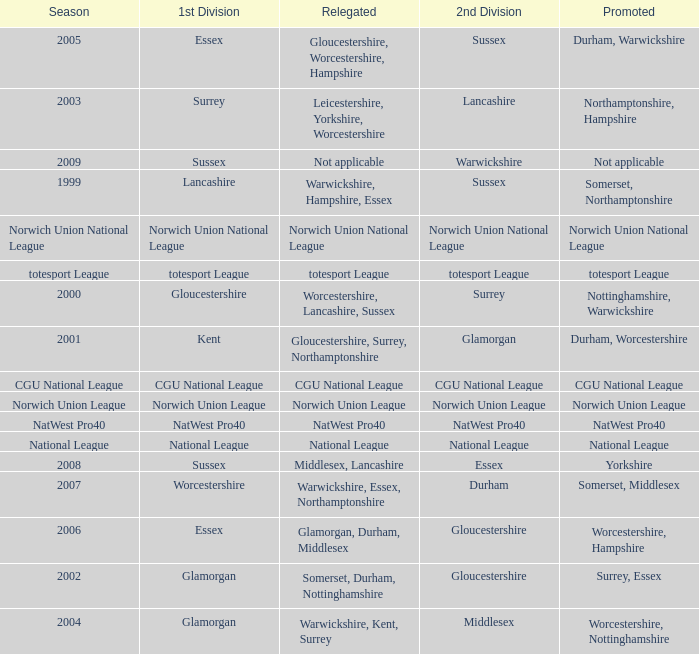What is the 1st division when the 2nd division is national league? National League. 